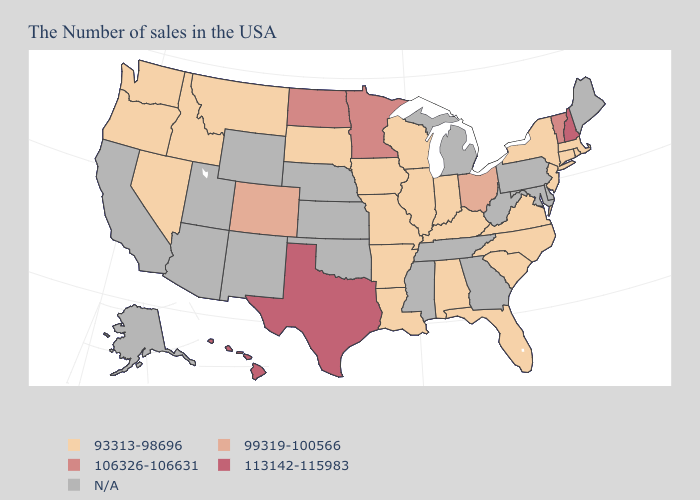Is the legend a continuous bar?
Concise answer only. No. What is the value of Georgia?
Keep it brief. N/A. Name the states that have a value in the range 99319-100566?
Short answer required. Ohio, Colorado. What is the lowest value in states that border New Jersey?
Concise answer only. 93313-98696. Does Massachusetts have the lowest value in the USA?
Concise answer only. Yes. Name the states that have a value in the range N/A?
Keep it brief. Maine, Delaware, Maryland, Pennsylvania, West Virginia, Georgia, Michigan, Tennessee, Mississippi, Kansas, Nebraska, Oklahoma, Wyoming, New Mexico, Utah, Arizona, California, Alaska. Does New Hampshire have the highest value in the Northeast?
Give a very brief answer. Yes. What is the highest value in the USA?
Short answer required. 113142-115983. Name the states that have a value in the range N/A?
Quick response, please. Maine, Delaware, Maryland, Pennsylvania, West Virginia, Georgia, Michigan, Tennessee, Mississippi, Kansas, Nebraska, Oklahoma, Wyoming, New Mexico, Utah, Arizona, California, Alaska. Name the states that have a value in the range 113142-115983?
Quick response, please. New Hampshire, Texas, Hawaii. Name the states that have a value in the range 93313-98696?
Be succinct. Massachusetts, Rhode Island, Connecticut, New York, New Jersey, Virginia, North Carolina, South Carolina, Florida, Kentucky, Indiana, Alabama, Wisconsin, Illinois, Louisiana, Missouri, Arkansas, Iowa, South Dakota, Montana, Idaho, Nevada, Washington, Oregon. Name the states that have a value in the range 106326-106631?
Keep it brief. Vermont, Minnesota, North Dakota. What is the highest value in states that border Ohio?
Write a very short answer. 93313-98696. Among the states that border Missouri , which have the highest value?
Quick response, please. Kentucky, Illinois, Arkansas, Iowa. 